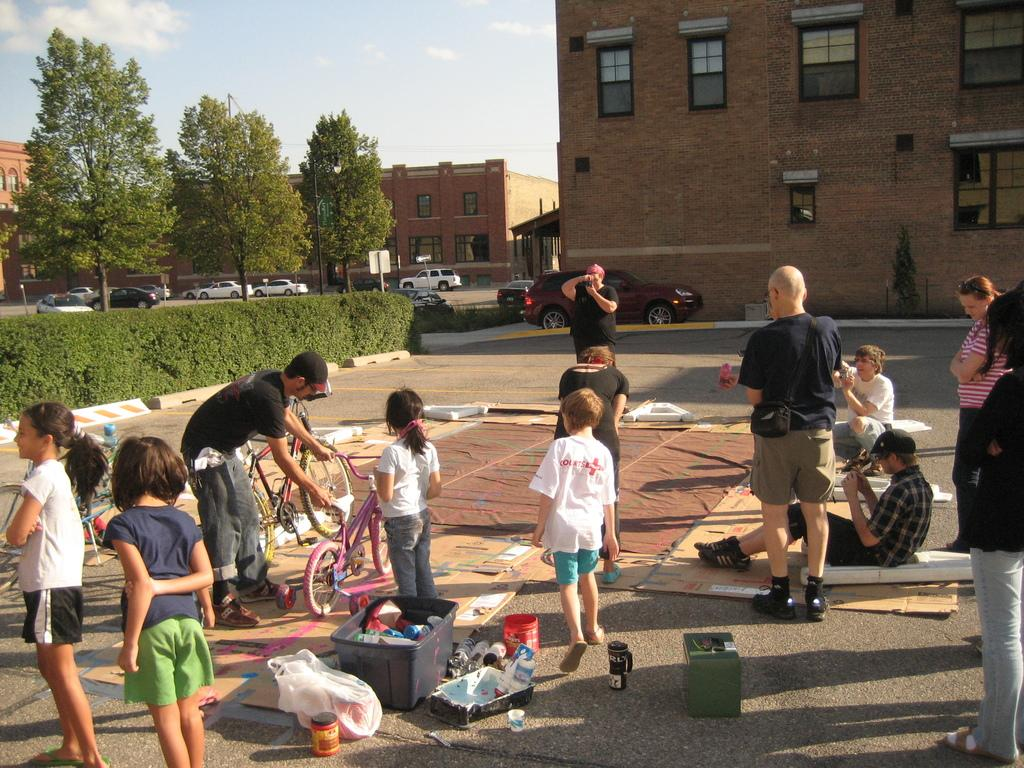What are the people in the image doing? There is a group of people sitting on a mat in the image. What can be seen in the vicinity of the people? There are cars in the vicinity. What type of vegetation is present in the area? There are plants in the area. What type of structures are nearby? There are buildings nearby. What book is the person reading in the image? There is no person reading a book in the image. What type of street can be seen in the image? There is no street present in the image. 